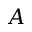<formula> <loc_0><loc_0><loc_500><loc_500>A</formula> 